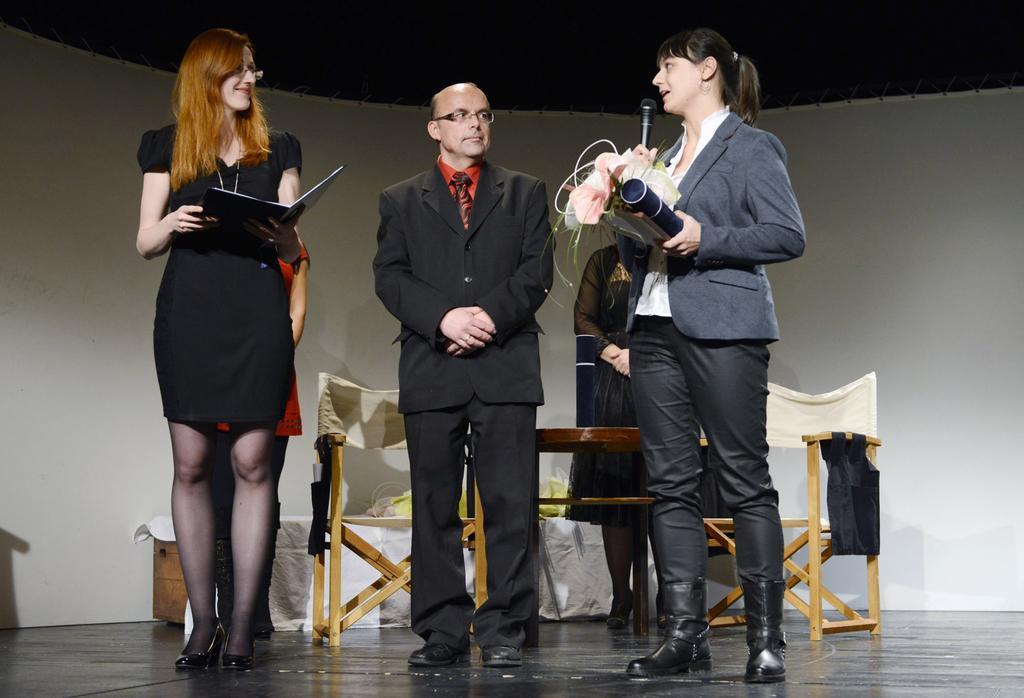Could you give a brief overview of what you see in this image? This image is taken indoors. At the bottom of the image there is a dais. In the background there is a wall and a woman is standing on the floor. There are a few empty chairs and a table with a cloth on it. In the middle of the image a man is standing on the dais and two women are standing and holding mics and a book in their hands. 